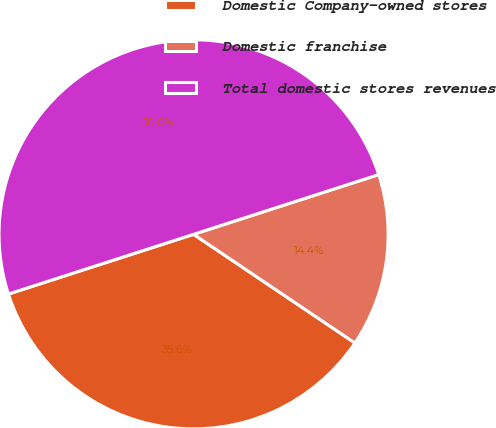<chart> <loc_0><loc_0><loc_500><loc_500><pie_chart><fcel>Domestic Company-owned stores<fcel>Domestic franchise<fcel>Total domestic stores revenues<nl><fcel>35.6%<fcel>14.4%<fcel>50.0%<nl></chart> 